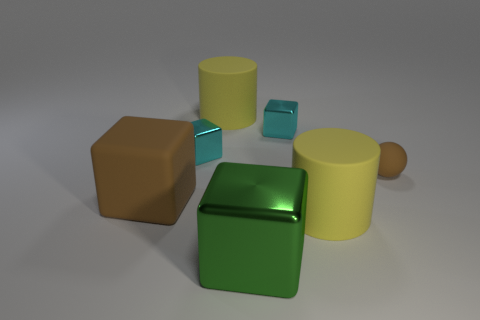Subtract all brown rubber blocks. How many blocks are left? 3 Subtract all brown spheres. How many cyan blocks are left? 2 Subtract all green cubes. How many cubes are left? 3 Add 1 tiny cyan shiny things. How many objects exist? 8 Subtract all purple blocks. Subtract all yellow cylinders. How many blocks are left? 4 Subtract all green blocks. Subtract all yellow rubber cylinders. How many objects are left? 4 Add 3 cyan blocks. How many cyan blocks are left? 5 Add 3 purple cylinders. How many purple cylinders exist? 3 Subtract 0 blue cylinders. How many objects are left? 7 Subtract all blocks. How many objects are left? 3 